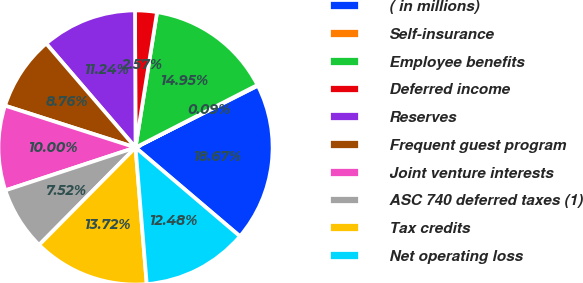Convert chart. <chart><loc_0><loc_0><loc_500><loc_500><pie_chart><fcel>( in millions)<fcel>Self-insurance<fcel>Employee benefits<fcel>Deferred income<fcel>Reserves<fcel>Frequent guest program<fcel>Joint venture interests<fcel>ASC 740 deferred taxes (1)<fcel>Tax credits<fcel>Net operating loss<nl><fcel>18.67%<fcel>0.09%<fcel>14.95%<fcel>2.57%<fcel>11.24%<fcel>8.76%<fcel>10.0%<fcel>7.52%<fcel>13.72%<fcel>12.48%<nl></chart> 